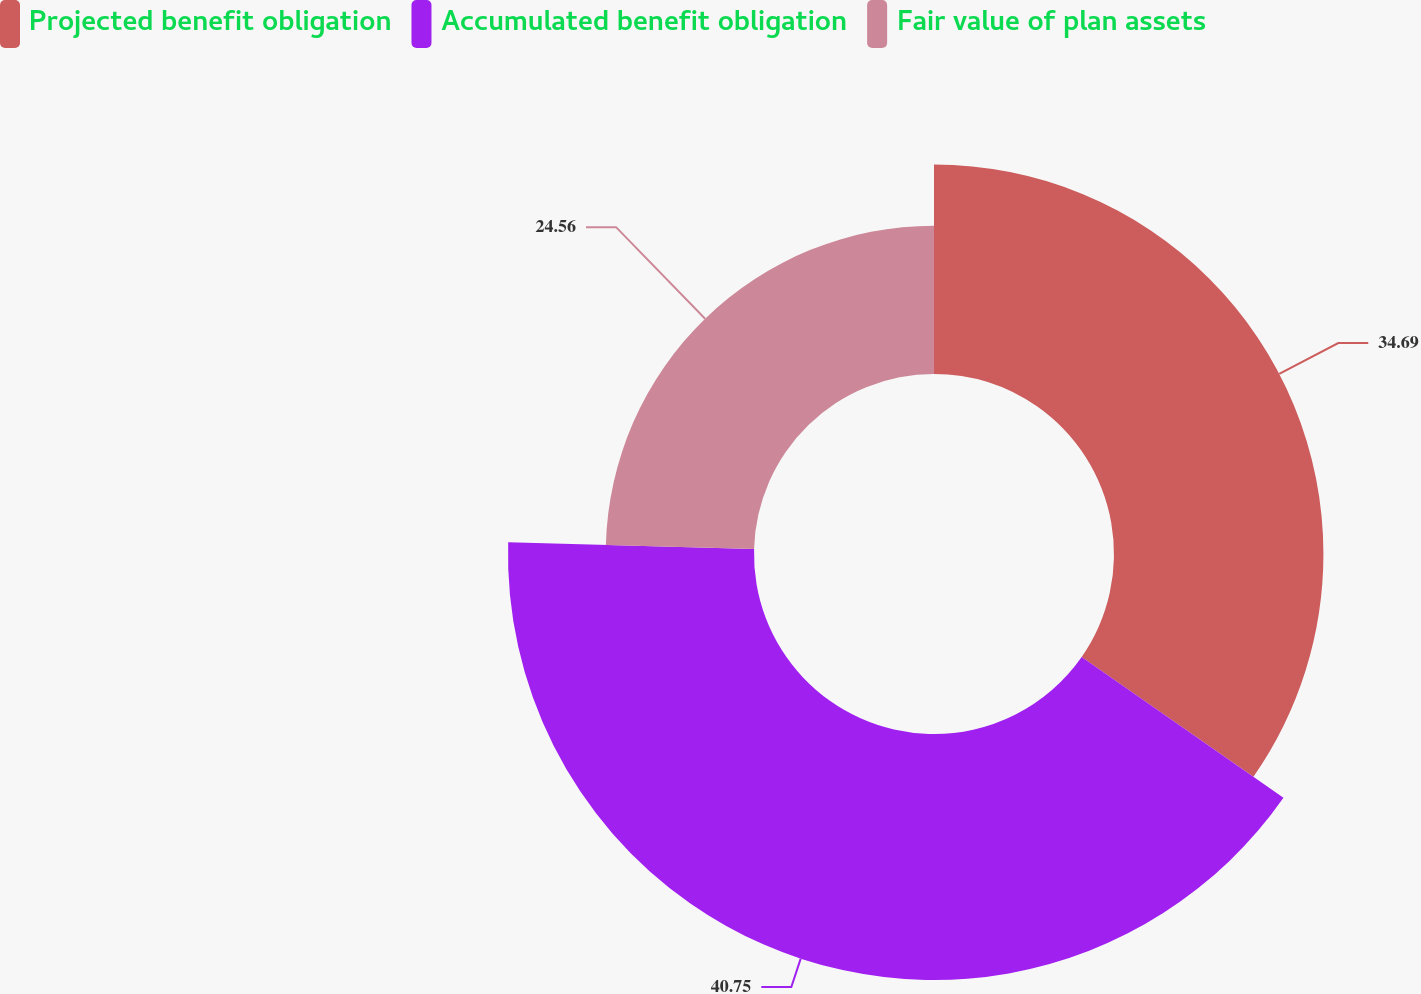Convert chart. <chart><loc_0><loc_0><loc_500><loc_500><pie_chart><fcel>Projected benefit obligation<fcel>Accumulated benefit obligation<fcel>Fair value of plan assets<nl><fcel>34.69%<fcel>40.75%<fcel>24.56%<nl></chart> 